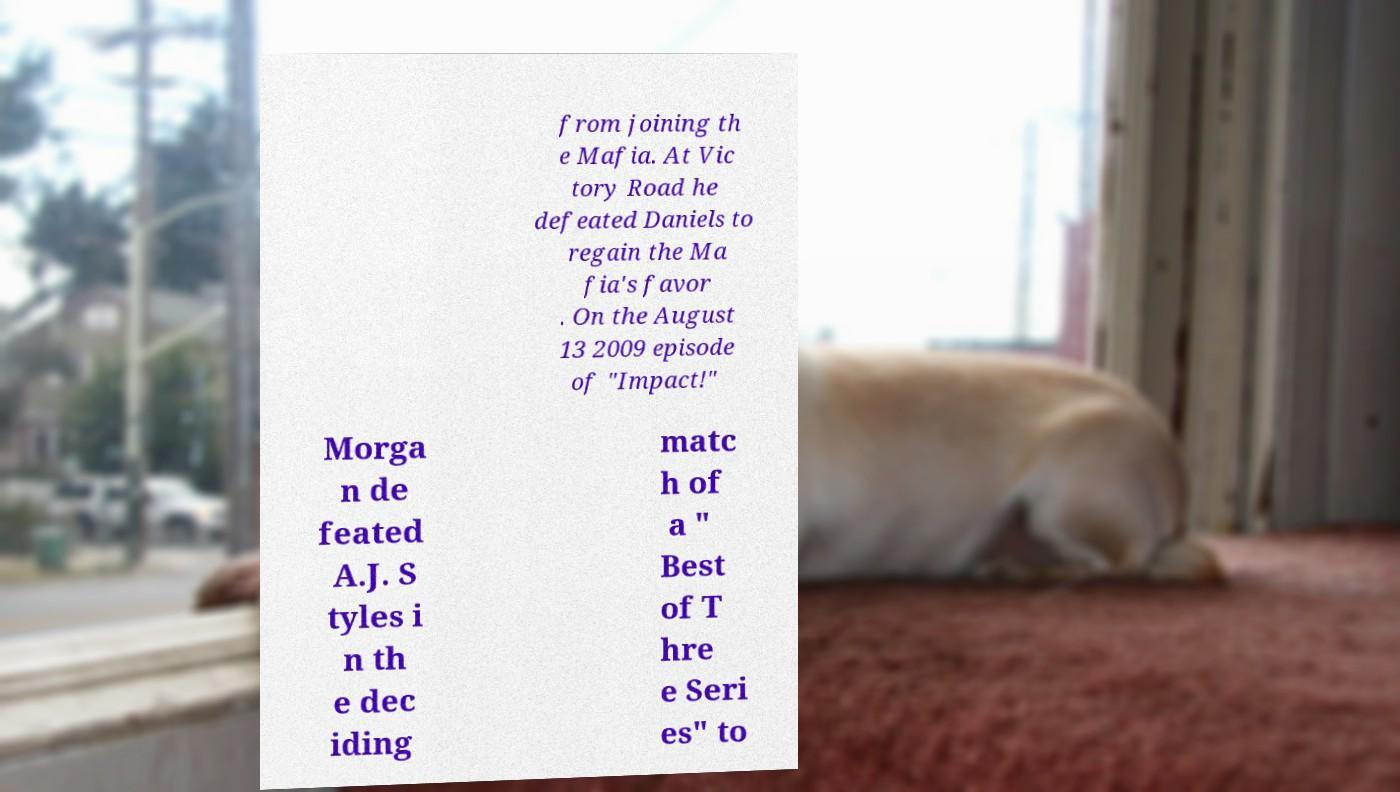Can you accurately transcribe the text from the provided image for me? from joining th e Mafia. At Vic tory Road he defeated Daniels to regain the Ma fia's favor . On the August 13 2009 episode of "Impact!" Morga n de feated A.J. S tyles i n th e dec iding matc h of a " Best of T hre e Seri es" to 